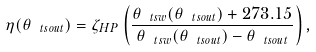<formula> <loc_0><loc_0><loc_500><loc_500>\eta ( \theta _ { \ t s { o u t } } ) = \zeta _ { H P } \left ( \frac { \theta _ { \ t s { w } } ( \theta _ { \ t s { o u t } } ) + 2 7 3 . 1 5 } { \theta _ { \ t s { w } } ( \theta _ { \ t s { o u t } } ) - \theta _ { \ t s { o u t } } } \right ) ,</formula> 